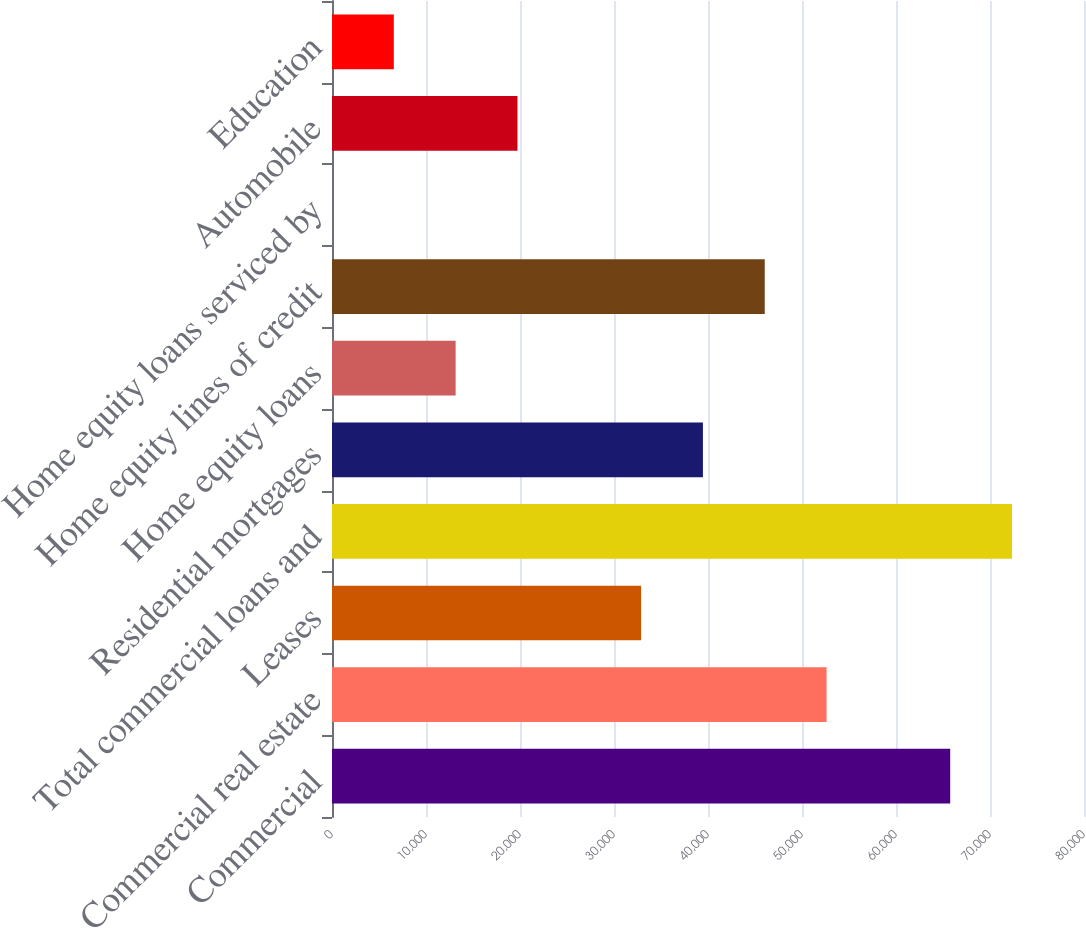Convert chart to OTSL. <chart><loc_0><loc_0><loc_500><loc_500><bar_chart><fcel>Commercial<fcel>Commercial real estate<fcel>Leases<fcel>Total commercial loans and<fcel>Residential mortgages<fcel>Home equity loans<fcel>Home equity lines of credit<fcel>Home equity loans serviced by<fcel>Automobile<fcel>Education<nl><fcel>65766<fcel>52613<fcel>32883.5<fcel>72342.5<fcel>39460<fcel>13154<fcel>46036.5<fcel>1<fcel>19730.5<fcel>6577.5<nl></chart> 